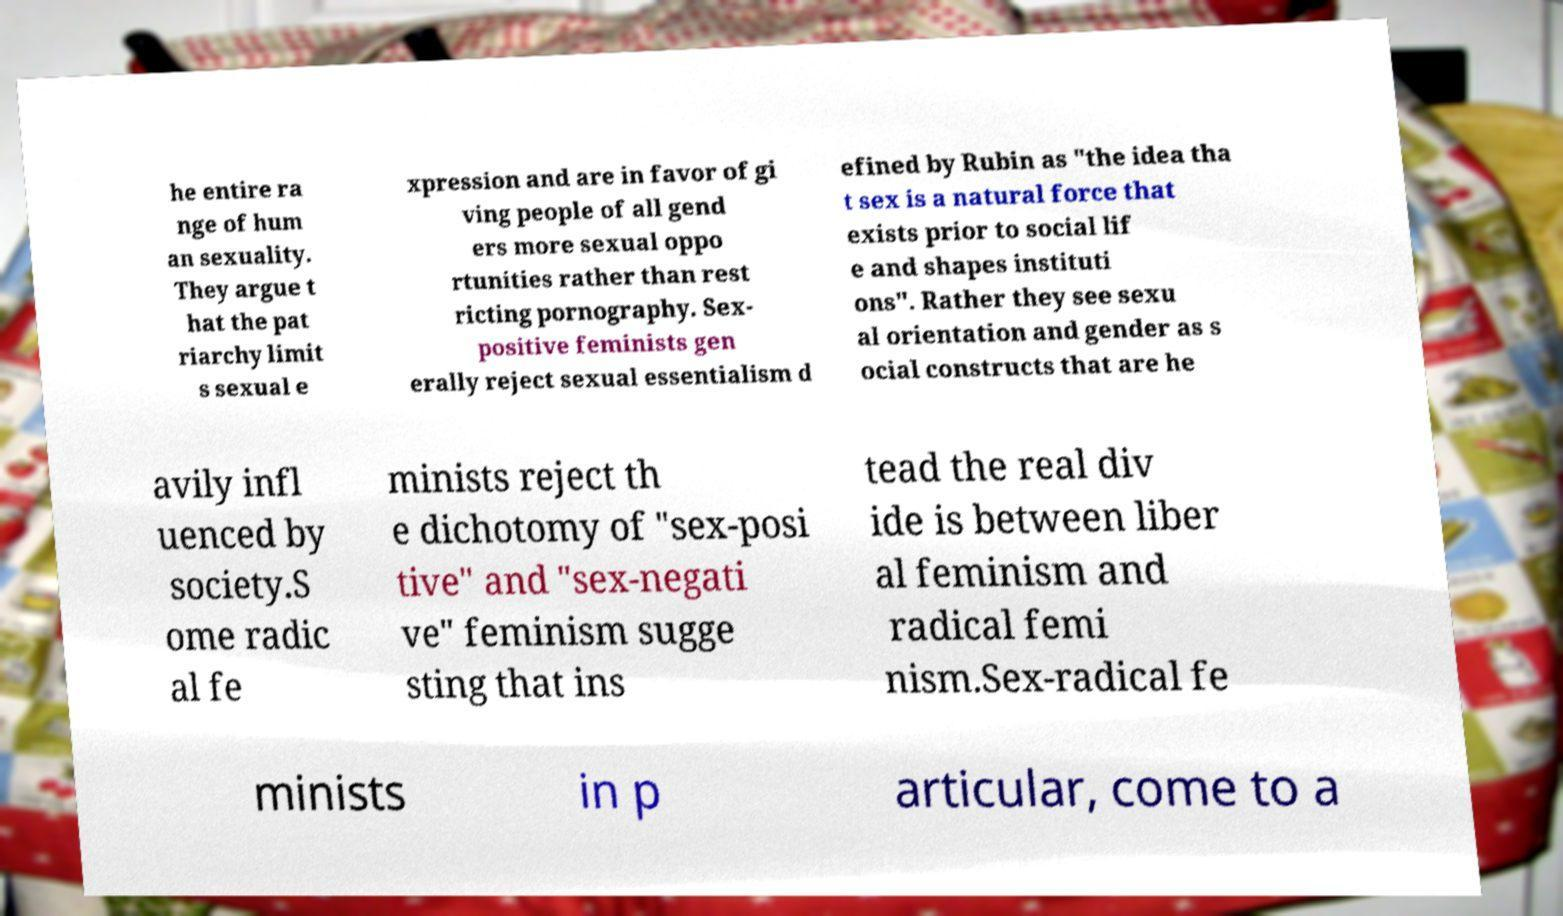Can you accurately transcribe the text from the provided image for me? he entire ra nge of hum an sexuality. They argue t hat the pat riarchy limit s sexual e xpression and are in favor of gi ving people of all gend ers more sexual oppo rtunities rather than rest ricting pornography. Sex- positive feminists gen erally reject sexual essentialism d efined by Rubin as "the idea tha t sex is a natural force that exists prior to social lif e and shapes instituti ons". Rather they see sexu al orientation and gender as s ocial constructs that are he avily infl uenced by society.S ome radic al fe minists reject th e dichotomy of "sex-posi tive" and "sex-negati ve" feminism sugge sting that ins tead the real div ide is between liber al feminism and radical femi nism.Sex-radical fe minists in p articular, come to a 